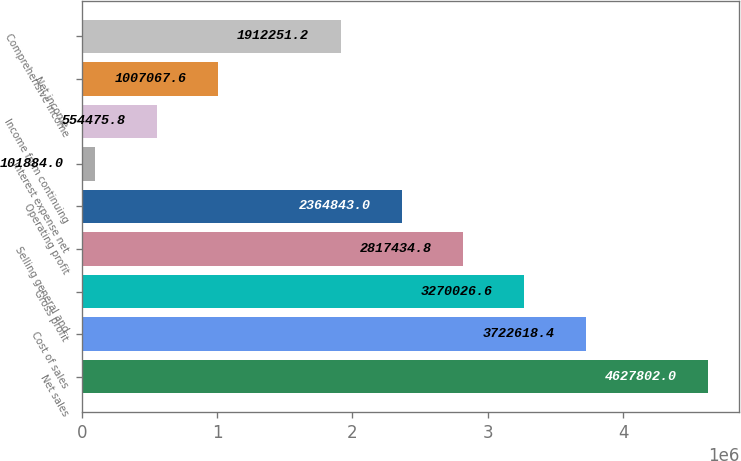Convert chart to OTSL. <chart><loc_0><loc_0><loc_500><loc_500><bar_chart><fcel>Net sales<fcel>Cost of sales<fcel>Gross profit<fcel>Selling general and<fcel>Operating profit<fcel>Interest expense net<fcel>Income from continuing<fcel>Net income<fcel>Comprehensive income<nl><fcel>4.6278e+06<fcel>3.72262e+06<fcel>3.27003e+06<fcel>2.81743e+06<fcel>2.36484e+06<fcel>101884<fcel>554476<fcel>1.00707e+06<fcel>1.91225e+06<nl></chart> 